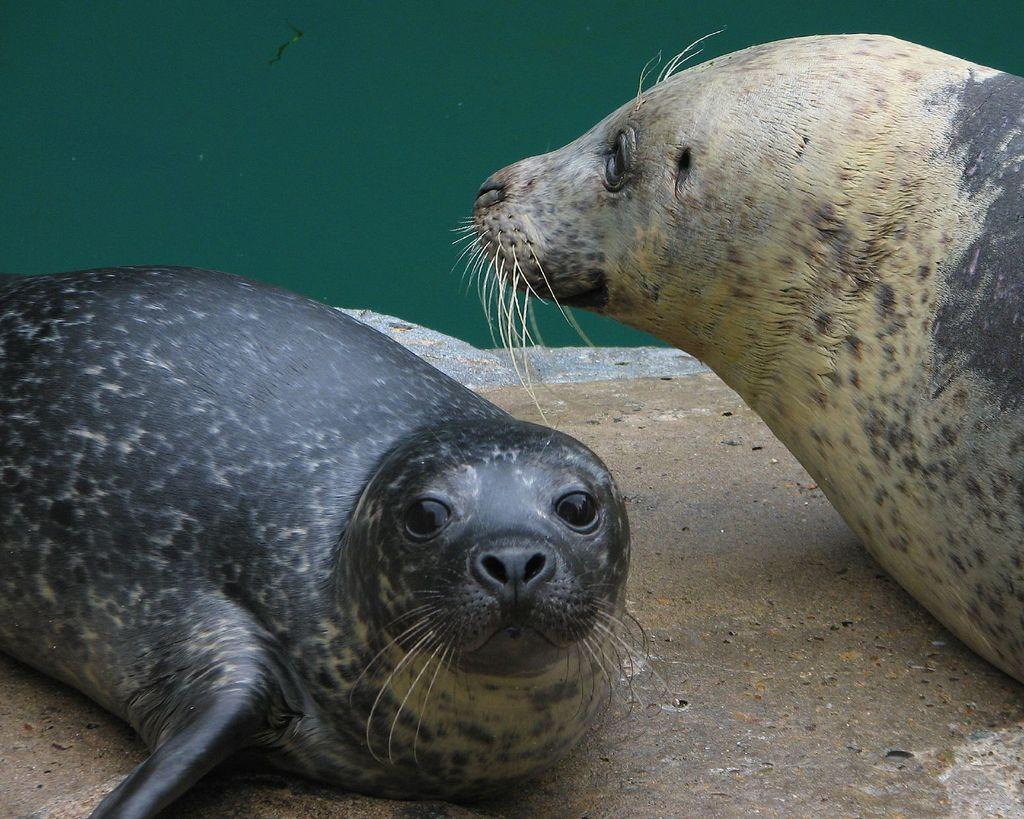How many seals are in the image? There are two seals in the image. What is the background of the image? There is water visible behind the seals. How many cents are visible in the image? There are no cents present in the image. What type of balloon can be seen floating in the water? There is no balloon present in the image. 